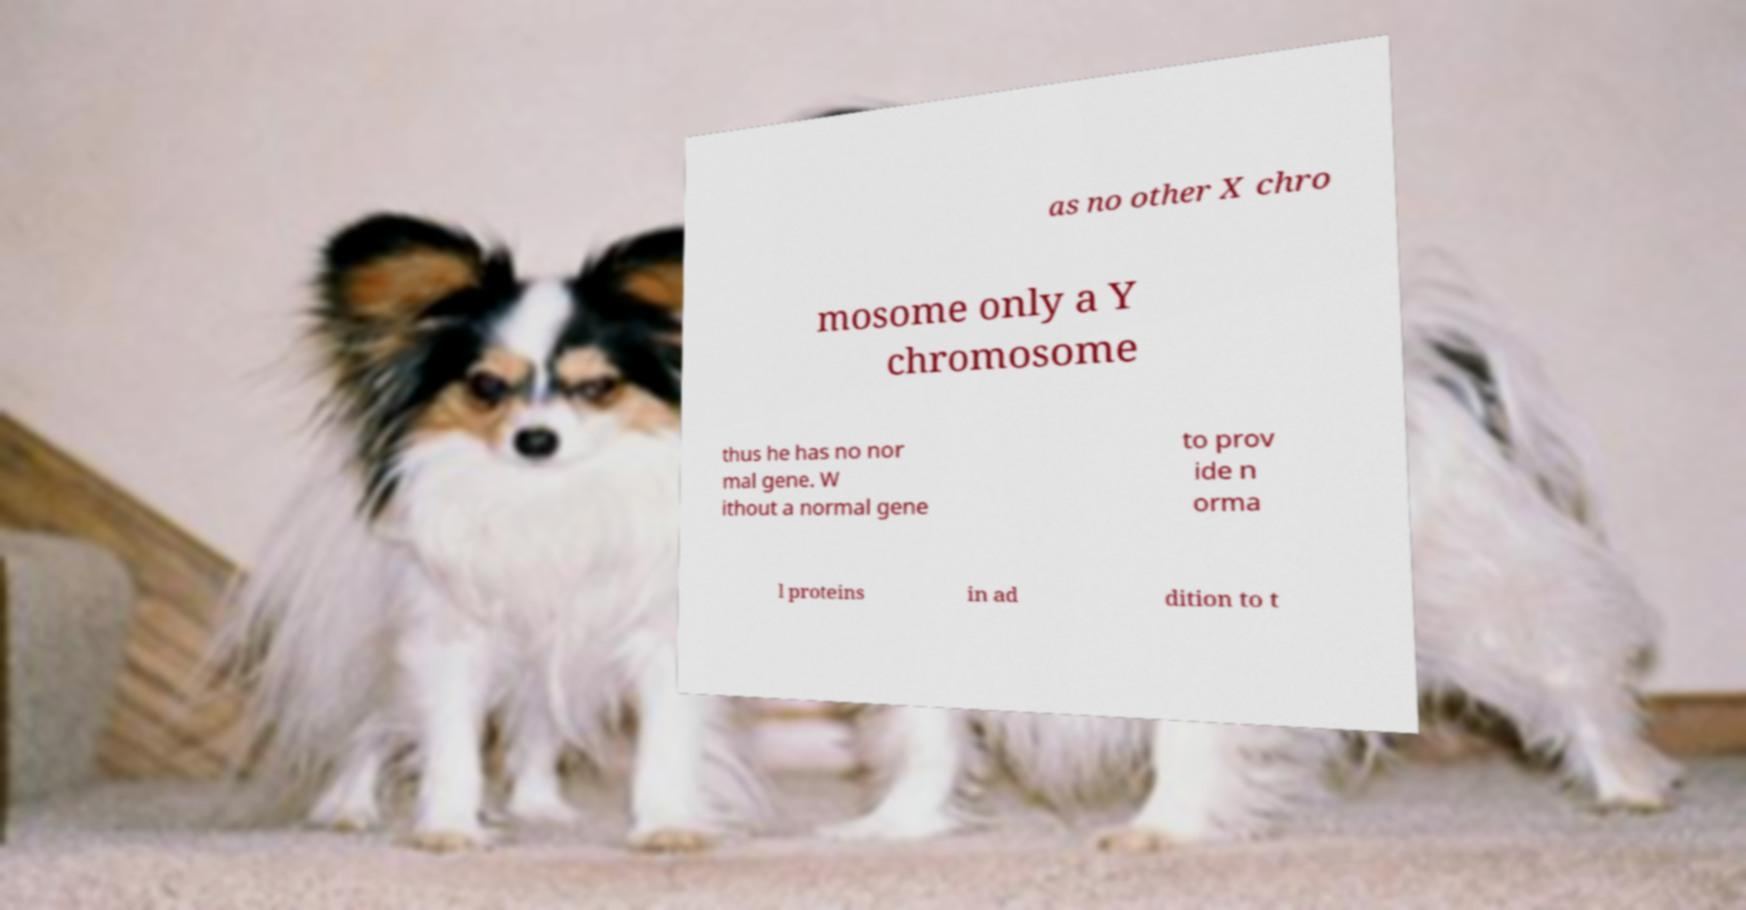For documentation purposes, I need the text within this image transcribed. Could you provide that? as no other X chro mosome only a Y chromosome thus he has no nor mal gene. W ithout a normal gene to prov ide n orma l proteins in ad dition to t 